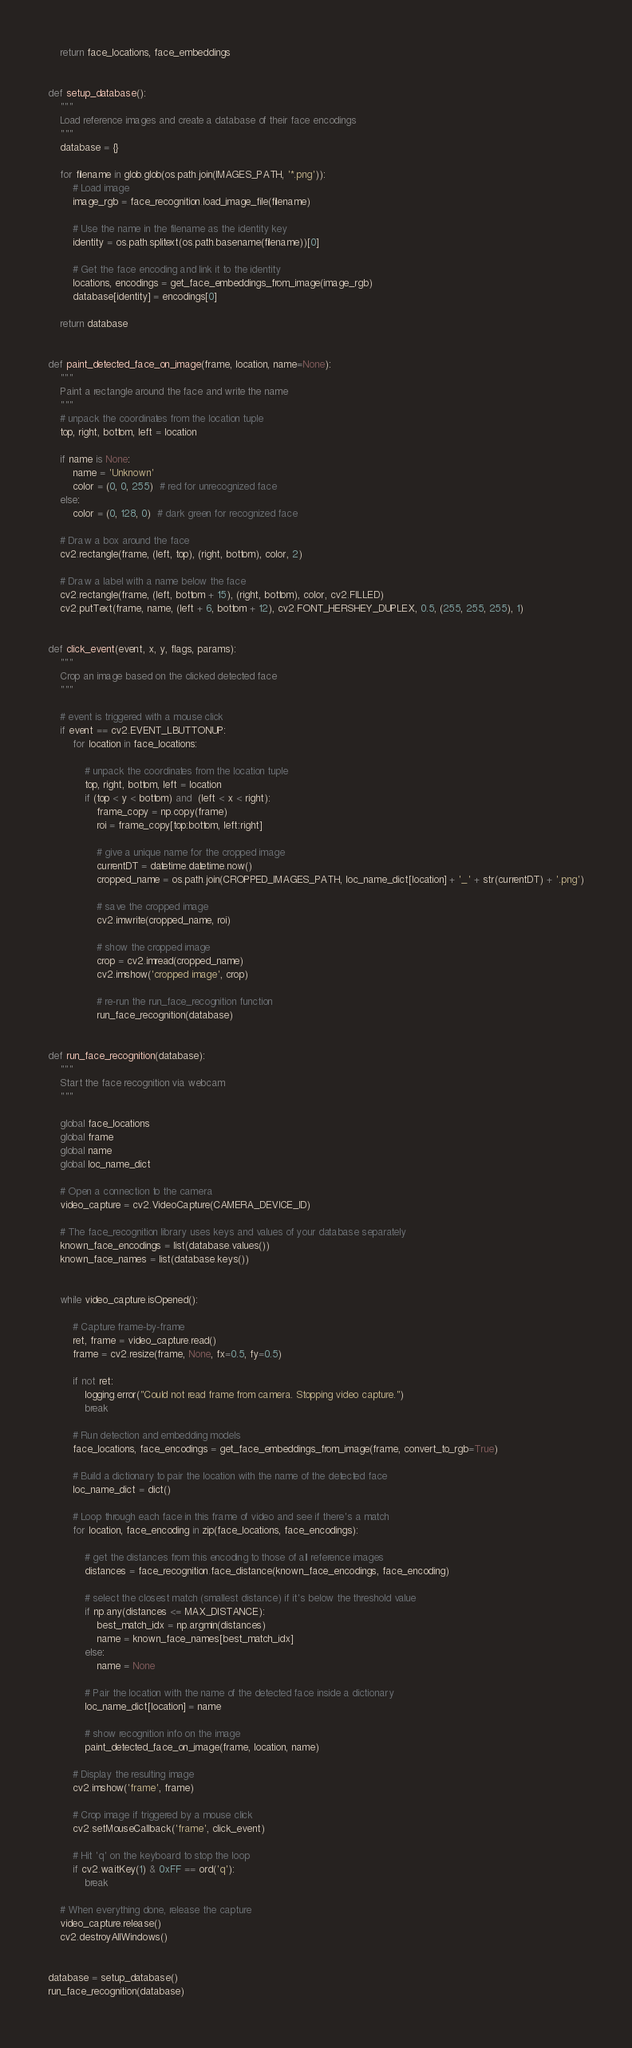<code> <loc_0><loc_0><loc_500><loc_500><_Python_>    return face_locations, face_embeddings


def setup_database():
    """
    Load reference images and create a database of their face encodings
    """
    database = {}
    
    for filename in glob.glob(os.path.join(IMAGES_PATH, '*.png')):
        # Load image
        image_rgb = face_recognition.load_image_file(filename)
        
        # Use the name in the filename as the identity key
        identity = os.path.splitext(os.path.basename(filename))[0]
        
        # Get the face encoding and link it to the identity
        locations, encodings = get_face_embeddings_from_image(image_rgb)
        database[identity] = encodings[0]
    
    return database


def paint_detected_face_on_image(frame, location, name=None):
    """
    Paint a rectangle around the face and write the name
    """
    # unpack the coordinates from the location tuple
    top, right, bottom, left = location
    
    if name is None:
        name = 'Unknown'
        color = (0, 0, 255)  # red for unrecognized face
    else:
        color = (0, 128, 0)  # dark green for recognized face
        
    # Draw a box around the face
    cv2.rectangle(frame, (left, top), (right, bottom), color, 2)
    
    # Draw a label with a name below the face
    cv2.rectangle(frame, (left, bottom + 15), (right, bottom), color, cv2.FILLED)
    cv2.putText(frame, name, (left + 6, bottom + 12), cv2.FONT_HERSHEY_DUPLEX, 0.5, (255, 255, 255), 1)


def click_event(event, x, y, flags, params):
    """
    Crop an image based on the clicked detected face
    """

    # event is triggered with a mouse click
    if event == cv2.EVENT_LBUTTONUP:
        for location in face_locations:

            # unpack the coordinates from the location tuple
            top, right, bottom, left = location
            if (top < y < bottom) and  (left < x < right):
                frame_copy = np.copy(frame)
                roi = frame_copy[top:bottom, left:right]

                # give a unique name for the cropped image
                currentDT = datetime.datetime.now()
                cropped_name = os.path.join(CROPPED_IMAGES_PATH, loc_name_dict[location] + '_' + str(currentDT) + '.png')

                # save the cropped image
                cv2.imwrite(cropped_name, roi)

                # show the cropped image
                crop = cv2.imread(cropped_name)
                cv2.imshow('cropped image', crop)

                # re-run the run_face_recognition function
                run_face_recognition(database)


def run_face_recognition(database):
    """
    Start the face recognition via webcam
    """
    
    global face_locations
    global frame
    global name
    global loc_name_dict

    # Open a connection to the camera
    video_capture = cv2.VideoCapture(CAMERA_DEVICE_ID)
    
    # The face_recognition library uses keys and values of your database separately
    known_face_encodings = list(database.values())
    known_face_names = list(database.keys())

    
    while video_capture.isOpened():
        
        # Capture frame-by-frame
        ret, frame = video_capture.read()
        frame = cv2.resize(frame, None, fx=0.5, fy=0.5)
        
        if not ret:
            logging.error("Could not read frame from camera. Stopping video capture.")
            break
        
        # Run detection and embedding models
        face_locations, face_encodings = get_face_embeddings_from_image(frame, convert_to_rgb=True)

        # Build a dictionary to pair the location with the name of the detected face 
        loc_name_dict = dict()
        
        # Loop through each face in this frame of video and see if there's a match
        for location, face_encoding in zip(face_locations, face_encodings):
            
            # get the distances from this encoding to those of all reference images
            distances = face_recognition.face_distance(known_face_encodings, face_encoding)
            
            # select the closest match (smallest distance) if it's below the threshold value
            if np.any(distances <= MAX_DISTANCE):
                best_match_idx = np.argmin(distances)
                name = known_face_names[best_match_idx]
            else:
                name = None
            
            # Pair the location with the name of the detected face inside a dictionary
            loc_name_dict[location] = name
            
            # show recognition info on the image
            paint_detected_face_on_image(frame, location, name)
            
        # Display the resulting image
        cv2.imshow('frame', frame)

        # Crop image if triggered by a mouse click
        cv2.setMouseCallback('frame', click_event)
    
        # Hit 'q' on the keyboard to stop the loop
        if cv2.waitKey(1) & 0xFF == ord('q'):
            break
            
    # When everything done, release the capture
    video_capture.release()
    cv2.destroyAllWindows()


database = setup_database()
run_face_recognition(database)</code> 